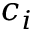Convert formula to latex. <formula><loc_0><loc_0><loc_500><loc_500>c _ { i }</formula> 